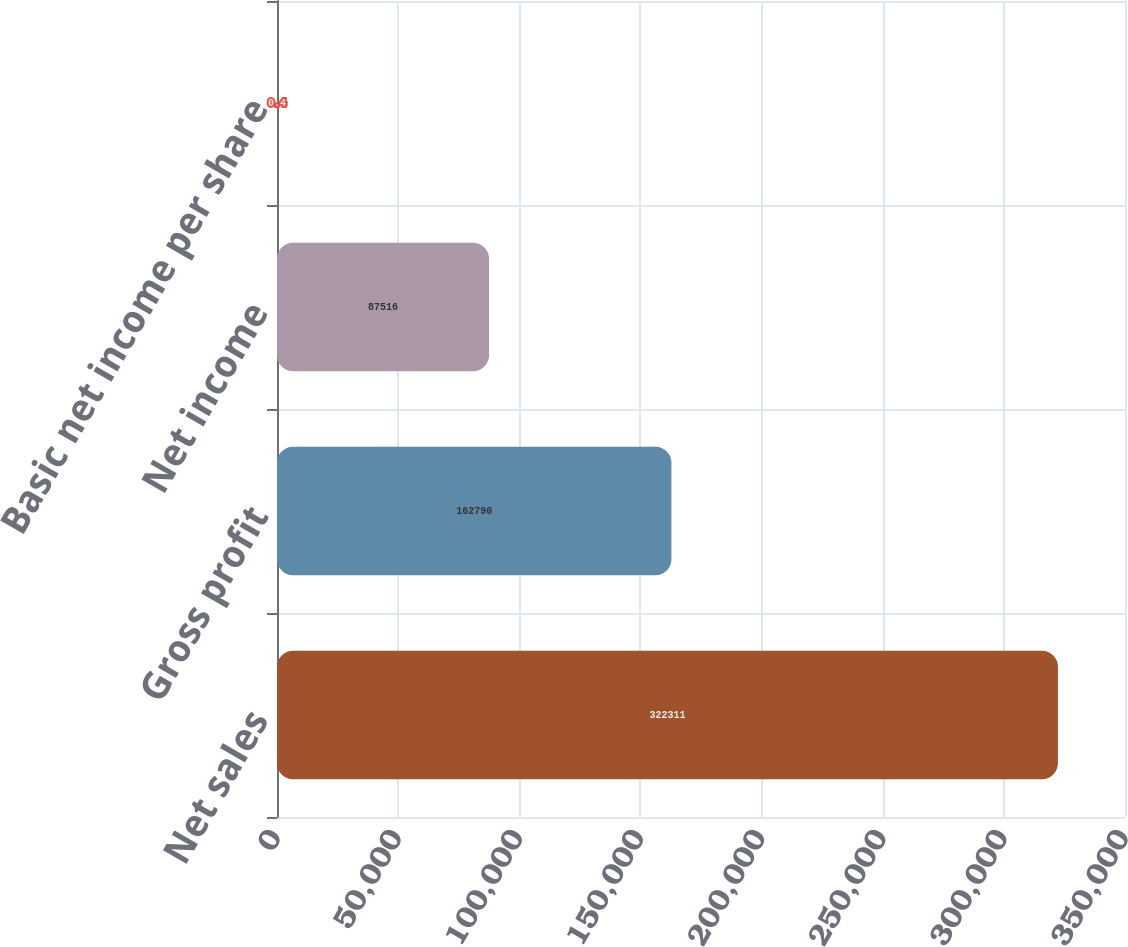Convert chart to OTSL. <chart><loc_0><loc_0><loc_500><loc_500><bar_chart><fcel>Net sales<fcel>Gross profit<fcel>Net income<fcel>Basic net income per share<nl><fcel>322311<fcel>162790<fcel>87516<fcel>0.4<nl></chart> 